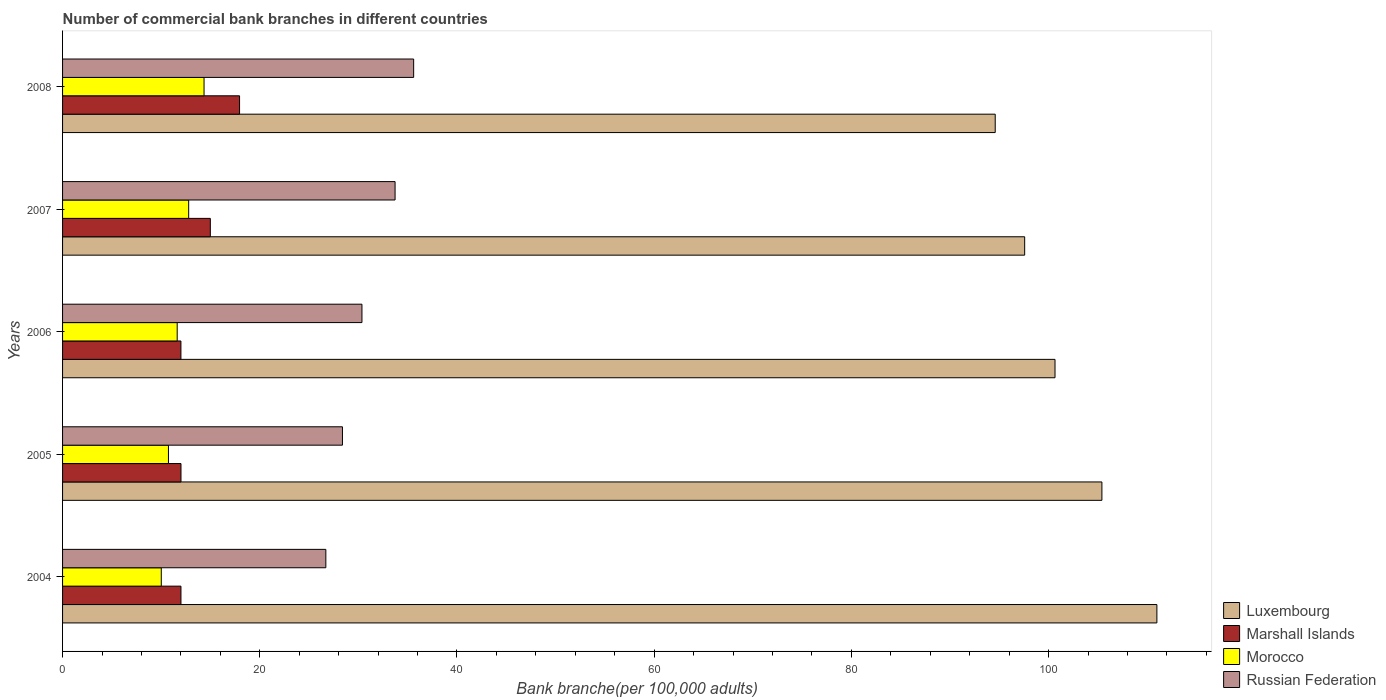How many different coloured bars are there?
Provide a short and direct response. 4. How many groups of bars are there?
Provide a succinct answer. 5. Are the number of bars per tick equal to the number of legend labels?
Provide a short and direct response. Yes. Are the number of bars on each tick of the Y-axis equal?
Your answer should be very brief. Yes. How many bars are there on the 3rd tick from the top?
Keep it short and to the point. 4. What is the label of the 5th group of bars from the top?
Your response must be concise. 2004. What is the number of commercial bank branches in Morocco in 2004?
Keep it short and to the point. 10.01. Across all years, what is the maximum number of commercial bank branches in Marshall Islands?
Your response must be concise. 17.95. Across all years, what is the minimum number of commercial bank branches in Russian Federation?
Offer a terse response. 26.7. In which year was the number of commercial bank branches in Marshall Islands maximum?
Provide a succinct answer. 2008. In which year was the number of commercial bank branches in Marshall Islands minimum?
Ensure brevity in your answer.  2006. What is the total number of commercial bank branches in Marshall Islands in the graph?
Offer a terse response. 68.95. What is the difference between the number of commercial bank branches in Russian Federation in 2004 and that in 2007?
Give a very brief answer. -7.02. What is the difference between the number of commercial bank branches in Luxembourg in 2004 and the number of commercial bank branches in Morocco in 2007?
Keep it short and to the point. 98.19. What is the average number of commercial bank branches in Morocco per year?
Provide a succinct answer. 11.9. In the year 2004, what is the difference between the number of commercial bank branches in Luxembourg and number of commercial bank branches in Russian Federation?
Your answer should be very brief. 84.28. In how many years, is the number of commercial bank branches in Morocco greater than 32 ?
Make the answer very short. 0. What is the ratio of the number of commercial bank branches in Luxembourg in 2005 to that in 2006?
Keep it short and to the point. 1.05. What is the difference between the highest and the second highest number of commercial bank branches in Luxembourg?
Provide a short and direct response. 5.58. What is the difference between the highest and the lowest number of commercial bank branches in Morocco?
Keep it short and to the point. 4.34. Is the sum of the number of commercial bank branches in Luxembourg in 2007 and 2008 greater than the maximum number of commercial bank branches in Russian Federation across all years?
Your answer should be very brief. Yes. Is it the case that in every year, the sum of the number of commercial bank branches in Marshall Islands and number of commercial bank branches in Luxembourg is greater than the sum of number of commercial bank branches in Morocco and number of commercial bank branches in Russian Federation?
Your answer should be very brief. Yes. What does the 1st bar from the top in 2007 represents?
Provide a short and direct response. Russian Federation. What does the 1st bar from the bottom in 2004 represents?
Provide a short and direct response. Luxembourg. Is it the case that in every year, the sum of the number of commercial bank branches in Marshall Islands and number of commercial bank branches in Morocco is greater than the number of commercial bank branches in Russian Federation?
Your answer should be compact. No. Does the graph contain any zero values?
Offer a terse response. No. How many legend labels are there?
Your answer should be very brief. 4. What is the title of the graph?
Offer a very short reply. Number of commercial bank branches in different countries. What is the label or title of the X-axis?
Keep it short and to the point. Bank branche(per 100,0 adults). What is the Bank branche(per 100,000 adults) in Luxembourg in 2004?
Ensure brevity in your answer.  110.98. What is the Bank branche(per 100,000 adults) in Marshall Islands in 2004?
Ensure brevity in your answer.  12.01. What is the Bank branche(per 100,000 adults) of Morocco in 2004?
Keep it short and to the point. 10.01. What is the Bank branche(per 100,000 adults) in Russian Federation in 2004?
Offer a terse response. 26.7. What is the Bank branche(per 100,000 adults) in Luxembourg in 2005?
Offer a terse response. 105.41. What is the Bank branche(per 100,000 adults) in Marshall Islands in 2005?
Give a very brief answer. 12.01. What is the Bank branche(per 100,000 adults) of Morocco in 2005?
Offer a very short reply. 10.74. What is the Bank branche(per 100,000 adults) of Russian Federation in 2005?
Your answer should be very brief. 28.38. What is the Bank branche(per 100,000 adults) in Luxembourg in 2006?
Provide a succinct answer. 100.65. What is the Bank branche(per 100,000 adults) in Marshall Islands in 2006?
Ensure brevity in your answer.  12. What is the Bank branche(per 100,000 adults) in Morocco in 2006?
Your answer should be very brief. 11.63. What is the Bank branche(per 100,000 adults) of Russian Federation in 2006?
Provide a short and direct response. 30.36. What is the Bank branche(per 100,000 adults) in Luxembourg in 2007?
Keep it short and to the point. 97.57. What is the Bank branche(per 100,000 adults) of Marshall Islands in 2007?
Provide a short and direct response. 14.99. What is the Bank branche(per 100,000 adults) in Morocco in 2007?
Keep it short and to the point. 12.79. What is the Bank branche(per 100,000 adults) of Russian Federation in 2007?
Offer a terse response. 33.72. What is the Bank branche(per 100,000 adults) in Luxembourg in 2008?
Provide a succinct answer. 94.59. What is the Bank branche(per 100,000 adults) in Marshall Islands in 2008?
Keep it short and to the point. 17.95. What is the Bank branche(per 100,000 adults) in Morocco in 2008?
Your answer should be very brief. 14.35. What is the Bank branche(per 100,000 adults) in Russian Federation in 2008?
Your response must be concise. 35.61. Across all years, what is the maximum Bank branche(per 100,000 adults) of Luxembourg?
Provide a short and direct response. 110.98. Across all years, what is the maximum Bank branche(per 100,000 adults) of Marshall Islands?
Provide a short and direct response. 17.95. Across all years, what is the maximum Bank branche(per 100,000 adults) of Morocco?
Make the answer very short. 14.35. Across all years, what is the maximum Bank branche(per 100,000 adults) of Russian Federation?
Keep it short and to the point. 35.61. Across all years, what is the minimum Bank branche(per 100,000 adults) in Luxembourg?
Give a very brief answer. 94.59. Across all years, what is the minimum Bank branche(per 100,000 adults) of Marshall Islands?
Ensure brevity in your answer.  12. Across all years, what is the minimum Bank branche(per 100,000 adults) in Morocco?
Provide a succinct answer. 10.01. Across all years, what is the minimum Bank branche(per 100,000 adults) of Russian Federation?
Provide a succinct answer. 26.7. What is the total Bank branche(per 100,000 adults) of Luxembourg in the graph?
Your response must be concise. 509.2. What is the total Bank branche(per 100,000 adults) in Marshall Islands in the graph?
Provide a succinct answer. 68.95. What is the total Bank branche(per 100,000 adults) in Morocco in the graph?
Offer a very short reply. 59.51. What is the total Bank branche(per 100,000 adults) of Russian Federation in the graph?
Offer a terse response. 154.78. What is the difference between the Bank branche(per 100,000 adults) of Luxembourg in 2004 and that in 2005?
Your answer should be very brief. 5.58. What is the difference between the Bank branche(per 100,000 adults) of Marshall Islands in 2004 and that in 2005?
Offer a terse response. -0. What is the difference between the Bank branche(per 100,000 adults) in Morocco in 2004 and that in 2005?
Provide a short and direct response. -0.73. What is the difference between the Bank branche(per 100,000 adults) in Russian Federation in 2004 and that in 2005?
Ensure brevity in your answer.  -1.68. What is the difference between the Bank branche(per 100,000 adults) of Luxembourg in 2004 and that in 2006?
Offer a very short reply. 10.33. What is the difference between the Bank branche(per 100,000 adults) of Marshall Islands in 2004 and that in 2006?
Your response must be concise. 0. What is the difference between the Bank branche(per 100,000 adults) of Morocco in 2004 and that in 2006?
Offer a terse response. -1.61. What is the difference between the Bank branche(per 100,000 adults) in Russian Federation in 2004 and that in 2006?
Provide a short and direct response. -3.66. What is the difference between the Bank branche(per 100,000 adults) of Luxembourg in 2004 and that in 2007?
Your answer should be very brief. 13.41. What is the difference between the Bank branche(per 100,000 adults) of Marshall Islands in 2004 and that in 2007?
Keep it short and to the point. -2.98. What is the difference between the Bank branche(per 100,000 adults) of Morocco in 2004 and that in 2007?
Provide a succinct answer. -2.78. What is the difference between the Bank branche(per 100,000 adults) in Russian Federation in 2004 and that in 2007?
Provide a succinct answer. -7.02. What is the difference between the Bank branche(per 100,000 adults) in Luxembourg in 2004 and that in 2008?
Offer a terse response. 16.4. What is the difference between the Bank branche(per 100,000 adults) of Marshall Islands in 2004 and that in 2008?
Your answer should be compact. -5.94. What is the difference between the Bank branche(per 100,000 adults) in Morocco in 2004 and that in 2008?
Make the answer very short. -4.34. What is the difference between the Bank branche(per 100,000 adults) of Russian Federation in 2004 and that in 2008?
Ensure brevity in your answer.  -8.91. What is the difference between the Bank branche(per 100,000 adults) of Luxembourg in 2005 and that in 2006?
Give a very brief answer. 4.76. What is the difference between the Bank branche(per 100,000 adults) in Marshall Islands in 2005 and that in 2006?
Your answer should be very brief. 0.01. What is the difference between the Bank branche(per 100,000 adults) of Morocco in 2005 and that in 2006?
Ensure brevity in your answer.  -0.89. What is the difference between the Bank branche(per 100,000 adults) in Russian Federation in 2005 and that in 2006?
Make the answer very short. -1.98. What is the difference between the Bank branche(per 100,000 adults) in Luxembourg in 2005 and that in 2007?
Keep it short and to the point. 7.83. What is the difference between the Bank branche(per 100,000 adults) of Marshall Islands in 2005 and that in 2007?
Make the answer very short. -2.98. What is the difference between the Bank branche(per 100,000 adults) in Morocco in 2005 and that in 2007?
Provide a short and direct response. -2.05. What is the difference between the Bank branche(per 100,000 adults) of Russian Federation in 2005 and that in 2007?
Your answer should be compact. -5.34. What is the difference between the Bank branche(per 100,000 adults) of Luxembourg in 2005 and that in 2008?
Offer a very short reply. 10.82. What is the difference between the Bank branche(per 100,000 adults) of Marshall Islands in 2005 and that in 2008?
Your answer should be very brief. -5.94. What is the difference between the Bank branche(per 100,000 adults) in Morocco in 2005 and that in 2008?
Your response must be concise. -3.61. What is the difference between the Bank branche(per 100,000 adults) of Russian Federation in 2005 and that in 2008?
Ensure brevity in your answer.  -7.22. What is the difference between the Bank branche(per 100,000 adults) of Luxembourg in 2006 and that in 2007?
Make the answer very short. 3.08. What is the difference between the Bank branche(per 100,000 adults) in Marshall Islands in 2006 and that in 2007?
Provide a succinct answer. -2.98. What is the difference between the Bank branche(per 100,000 adults) of Morocco in 2006 and that in 2007?
Ensure brevity in your answer.  -1.16. What is the difference between the Bank branche(per 100,000 adults) in Russian Federation in 2006 and that in 2007?
Your answer should be compact. -3.36. What is the difference between the Bank branche(per 100,000 adults) of Luxembourg in 2006 and that in 2008?
Offer a terse response. 6.06. What is the difference between the Bank branche(per 100,000 adults) of Marshall Islands in 2006 and that in 2008?
Offer a very short reply. -5.95. What is the difference between the Bank branche(per 100,000 adults) of Morocco in 2006 and that in 2008?
Provide a succinct answer. -2.72. What is the difference between the Bank branche(per 100,000 adults) of Russian Federation in 2006 and that in 2008?
Offer a terse response. -5.24. What is the difference between the Bank branche(per 100,000 adults) of Luxembourg in 2007 and that in 2008?
Offer a terse response. 2.99. What is the difference between the Bank branche(per 100,000 adults) in Marshall Islands in 2007 and that in 2008?
Your response must be concise. -2.96. What is the difference between the Bank branche(per 100,000 adults) in Morocco in 2007 and that in 2008?
Keep it short and to the point. -1.56. What is the difference between the Bank branche(per 100,000 adults) of Russian Federation in 2007 and that in 2008?
Your answer should be very brief. -1.89. What is the difference between the Bank branche(per 100,000 adults) in Luxembourg in 2004 and the Bank branche(per 100,000 adults) in Marshall Islands in 2005?
Keep it short and to the point. 98.97. What is the difference between the Bank branche(per 100,000 adults) in Luxembourg in 2004 and the Bank branche(per 100,000 adults) in Morocco in 2005?
Your response must be concise. 100.24. What is the difference between the Bank branche(per 100,000 adults) of Luxembourg in 2004 and the Bank branche(per 100,000 adults) of Russian Federation in 2005?
Your answer should be very brief. 82.6. What is the difference between the Bank branche(per 100,000 adults) of Marshall Islands in 2004 and the Bank branche(per 100,000 adults) of Morocco in 2005?
Provide a succinct answer. 1.27. What is the difference between the Bank branche(per 100,000 adults) in Marshall Islands in 2004 and the Bank branche(per 100,000 adults) in Russian Federation in 2005?
Your response must be concise. -16.38. What is the difference between the Bank branche(per 100,000 adults) in Morocco in 2004 and the Bank branche(per 100,000 adults) in Russian Federation in 2005?
Offer a terse response. -18.37. What is the difference between the Bank branche(per 100,000 adults) in Luxembourg in 2004 and the Bank branche(per 100,000 adults) in Marshall Islands in 2006?
Give a very brief answer. 98.98. What is the difference between the Bank branche(per 100,000 adults) in Luxembourg in 2004 and the Bank branche(per 100,000 adults) in Morocco in 2006?
Offer a terse response. 99.36. What is the difference between the Bank branche(per 100,000 adults) in Luxembourg in 2004 and the Bank branche(per 100,000 adults) in Russian Federation in 2006?
Keep it short and to the point. 80.62. What is the difference between the Bank branche(per 100,000 adults) of Marshall Islands in 2004 and the Bank branche(per 100,000 adults) of Morocco in 2006?
Your answer should be compact. 0.38. What is the difference between the Bank branche(per 100,000 adults) in Marshall Islands in 2004 and the Bank branche(per 100,000 adults) in Russian Federation in 2006?
Ensure brevity in your answer.  -18.36. What is the difference between the Bank branche(per 100,000 adults) of Morocco in 2004 and the Bank branche(per 100,000 adults) of Russian Federation in 2006?
Your answer should be very brief. -20.35. What is the difference between the Bank branche(per 100,000 adults) of Luxembourg in 2004 and the Bank branche(per 100,000 adults) of Marshall Islands in 2007?
Make the answer very short. 96. What is the difference between the Bank branche(per 100,000 adults) of Luxembourg in 2004 and the Bank branche(per 100,000 adults) of Morocco in 2007?
Your answer should be very brief. 98.19. What is the difference between the Bank branche(per 100,000 adults) in Luxembourg in 2004 and the Bank branche(per 100,000 adults) in Russian Federation in 2007?
Keep it short and to the point. 77.26. What is the difference between the Bank branche(per 100,000 adults) of Marshall Islands in 2004 and the Bank branche(per 100,000 adults) of Morocco in 2007?
Offer a terse response. -0.78. What is the difference between the Bank branche(per 100,000 adults) of Marshall Islands in 2004 and the Bank branche(per 100,000 adults) of Russian Federation in 2007?
Provide a short and direct response. -21.72. What is the difference between the Bank branche(per 100,000 adults) in Morocco in 2004 and the Bank branche(per 100,000 adults) in Russian Federation in 2007?
Give a very brief answer. -23.71. What is the difference between the Bank branche(per 100,000 adults) of Luxembourg in 2004 and the Bank branche(per 100,000 adults) of Marshall Islands in 2008?
Offer a very short reply. 93.03. What is the difference between the Bank branche(per 100,000 adults) in Luxembourg in 2004 and the Bank branche(per 100,000 adults) in Morocco in 2008?
Your response must be concise. 96.63. What is the difference between the Bank branche(per 100,000 adults) of Luxembourg in 2004 and the Bank branche(per 100,000 adults) of Russian Federation in 2008?
Give a very brief answer. 75.38. What is the difference between the Bank branche(per 100,000 adults) of Marshall Islands in 2004 and the Bank branche(per 100,000 adults) of Morocco in 2008?
Offer a terse response. -2.34. What is the difference between the Bank branche(per 100,000 adults) in Marshall Islands in 2004 and the Bank branche(per 100,000 adults) in Russian Federation in 2008?
Provide a short and direct response. -23.6. What is the difference between the Bank branche(per 100,000 adults) of Morocco in 2004 and the Bank branche(per 100,000 adults) of Russian Federation in 2008?
Ensure brevity in your answer.  -25.6. What is the difference between the Bank branche(per 100,000 adults) in Luxembourg in 2005 and the Bank branche(per 100,000 adults) in Marshall Islands in 2006?
Offer a very short reply. 93.4. What is the difference between the Bank branche(per 100,000 adults) of Luxembourg in 2005 and the Bank branche(per 100,000 adults) of Morocco in 2006?
Your answer should be very brief. 93.78. What is the difference between the Bank branche(per 100,000 adults) in Luxembourg in 2005 and the Bank branche(per 100,000 adults) in Russian Federation in 2006?
Offer a terse response. 75.04. What is the difference between the Bank branche(per 100,000 adults) of Marshall Islands in 2005 and the Bank branche(per 100,000 adults) of Morocco in 2006?
Your answer should be compact. 0.38. What is the difference between the Bank branche(per 100,000 adults) of Marshall Islands in 2005 and the Bank branche(per 100,000 adults) of Russian Federation in 2006?
Offer a terse response. -18.35. What is the difference between the Bank branche(per 100,000 adults) of Morocco in 2005 and the Bank branche(per 100,000 adults) of Russian Federation in 2006?
Your response must be concise. -19.62. What is the difference between the Bank branche(per 100,000 adults) of Luxembourg in 2005 and the Bank branche(per 100,000 adults) of Marshall Islands in 2007?
Offer a terse response. 90.42. What is the difference between the Bank branche(per 100,000 adults) in Luxembourg in 2005 and the Bank branche(per 100,000 adults) in Morocco in 2007?
Provide a short and direct response. 92.62. What is the difference between the Bank branche(per 100,000 adults) in Luxembourg in 2005 and the Bank branche(per 100,000 adults) in Russian Federation in 2007?
Offer a very short reply. 71.69. What is the difference between the Bank branche(per 100,000 adults) in Marshall Islands in 2005 and the Bank branche(per 100,000 adults) in Morocco in 2007?
Provide a short and direct response. -0.78. What is the difference between the Bank branche(per 100,000 adults) of Marshall Islands in 2005 and the Bank branche(per 100,000 adults) of Russian Federation in 2007?
Offer a very short reply. -21.71. What is the difference between the Bank branche(per 100,000 adults) of Morocco in 2005 and the Bank branche(per 100,000 adults) of Russian Federation in 2007?
Offer a very short reply. -22.98. What is the difference between the Bank branche(per 100,000 adults) in Luxembourg in 2005 and the Bank branche(per 100,000 adults) in Marshall Islands in 2008?
Provide a succinct answer. 87.46. What is the difference between the Bank branche(per 100,000 adults) in Luxembourg in 2005 and the Bank branche(per 100,000 adults) in Morocco in 2008?
Your answer should be compact. 91.06. What is the difference between the Bank branche(per 100,000 adults) of Luxembourg in 2005 and the Bank branche(per 100,000 adults) of Russian Federation in 2008?
Your response must be concise. 69.8. What is the difference between the Bank branche(per 100,000 adults) in Marshall Islands in 2005 and the Bank branche(per 100,000 adults) in Morocco in 2008?
Make the answer very short. -2.34. What is the difference between the Bank branche(per 100,000 adults) of Marshall Islands in 2005 and the Bank branche(per 100,000 adults) of Russian Federation in 2008?
Provide a succinct answer. -23.6. What is the difference between the Bank branche(per 100,000 adults) of Morocco in 2005 and the Bank branche(per 100,000 adults) of Russian Federation in 2008?
Your answer should be compact. -24.87. What is the difference between the Bank branche(per 100,000 adults) of Luxembourg in 2006 and the Bank branche(per 100,000 adults) of Marshall Islands in 2007?
Give a very brief answer. 85.67. What is the difference between the Bank branche(per 100,000 adults) in Luxembourg in 2006 and the Bank branche(per 100,000 adults) in Morocco in 2007?
Make the answer very short. 87.86. What is the difference between the Bank branche(per 100,000 adults) of Luxembourg in 2006 and the Bank branche(per 100,000 adults) of Russian Federation in 2007?
Your response must be concise. 66.93. What is the difference between the Bank branche(per 100,000 adults) of Marshall Islands in 2006 and the Bank branche(per 100,000 adults) of Morocco in 2007?
Provide a succinct answer. -0.79. What is the difference between the Bank branche(per 100,000 adults) in Marshall Islands in 2006 and the Bank branche(per 100,000 adults) in Russian Federation in 2007?
Ensure brevity in your answer.  -21.72. What is the difference between the Bank branche(per 100,000 adults) in Morocco in 2006 and the Bank branche(per 100,000 adults) in Russian Federation in 2007?
Offer a terse response. -22.1. What is the difference between the Bank branche(per 100,000 adults) of Luxembourg in 2006 and the Bank branche(per 100,000 adults) of Marshall Islands in 2008?
Offer a very short reply. 82.7. What is the difference between the Bank branche(per 100,000 adults) of Luxembourg in 2006 and the Bank branche(per 100,000 adults) of Morocco in 2008?
Provide a succinct answer. 86.3. What is the difference between the Bank branche(per 100,000 adults) of Luxembourg in 2006 and the Bank branche(per 100,000 adults) of Russian Federation in 2008?
Give a very brief answer. 65.04. What is the difference between the Bank branche(per 100,000 adults) of Marshall Islands in 2006 and the Bank branche(per 100,000 adults) of Morocco in 2008?
Keep it short and to the point. -2.35. What is the difference between the Bank branche(per 100,000 adults) of Marshall Islands in 2006 and the Bank branche(per 100,000 adults) of Russian Federation in 2008?
Your answer should be very brief. -23.6. What is the difference between the Bank branche(per 100,000 adults) of Morocco in 2006 and the Bank branche(per 100,000 adults) of Russian Federation in 2008?
Provide a short and direct response. -23.98. What is the difference between the Bank branche(per 100,000 adults) of Luxembourg in 2007 and the Bank branche(per 100,000 adults) of Marshall Islands in 2008?
Make the answer very short. 79.62. What is the difference between the Bank branche(per 100,000 adults) in Luxembourg in 2007 and the Bank branche(per 100,000 adults) in Morocco in 2008?
Your answer should be very brief. 83.22. What is the difference between the Bank branche(per 100,000 adults) in Luxembourg in 2007 and the Bank branche(per 100,000 adults) in Russian Federation in 2008?
Provide a short and direct response. 61.97. What is the difference between the Bank branche(per 100,000 adults) of Marshall Islands in 2007 and the Bank branche(per 100,000 adults) of Morocco in 2008?
Provide a short and direct response. 0.64. What is the difference between the Bank branche(per 100,000 adults) of Marshall Islands in 2007 and the Bank branche(per 100,000 adults) of Russian Federation in 2008?
Keep it short and to the point. -20.62. What is the difference between the Bank branche(per 100,000 adults) of Morocco in 2007 and the Bank branche(per 100,000 adults) of Russian Federation in 2008?
Your answer should be compact. -22.82. What is the average Bank branche(per 100,000 adults) in Luxembourg per year?
Your response must be concise. 101.84. What is the average Bank branche(per 100,000 adults) in Marshall Islands per year?
Your response must be concise. 13.79. What is the average Bank branche(per 100,000 adults) in Morocco per year?
Give a very brief answer. 11.9. What is the average Bank branche(per 100,000 adults) in Russian Federation per year?
Offer a terse response. 30.96. In the year 2004, what is the difference between the Bank branche(per 100,000 adults) of Luxembourg and Bank branche(per 100,000 adults) of Marshall Islands?
Make the answer very short. 98.98. In the year 2004, what is the difference between the Bank branche(per 100,000 adults) of Luxembourg and Bank branche(per 100,000 adults) of Morocco?
Make the answer very short. 100.97. In the year 2004, what is the difference between the Bank branche(per 100,000 adults) of Luxembourg and Bank branche(per 100,000 adults) of Russian Federation?
Offer a terse response. 84.28. In the year 2004, what is the difference between the Bank branche(per 100,000 adults) of Marshall Islands and Bank branche(per 100,000 adults) of Morocco?
Make the answer very short. 1.99. In the year 2004, what is the difference between the Bank branche(per 100,000 adults) in Marshall Islands and Bank branche(per 100,000 adults) in Russian Federation?
Your answer should be compact. -14.69. In the year 2004, what is the difference between the Bank branche(per 100,000 adults) of Morocco and Bank branche(per 100,000 adults) of Russian Federation?
Your answer should be very brief. -16.69. In the year 2005, what is the difference between the Bank branche(per 100,000 adults) of Luxembourg and Bank branche(per 100,000 adults) of Marshall Islands?
Make the answer very short. 93.4. In the year 2005, what is the difference between the Bank branche(per 100,000 adults) in Luxembourg and Bank branche(per 100,000 adults) in Morocco?
Make the answer very short. 94.67. In the year 2005, what is the difference between the Bank branche(per 100,000 adults) in Luxembourg and Bank branche(per 100,000 adults) in Russian Federation?
Provide a succinct answer. 77.02. In the year 2005, what is the difference between the Bank branche(per 100,000 adults) of Marshall Islands and Bank branche(per 100,000 adults) of Morocco?
Ensure brevity in your answer.  1.27. In the year 2005, what is the difference between the Bank branche(per 100,000 adults) of Marshall Islands and Bank branche(per 100,000 adults) of Russian Federation?
Ensure brevity in your answer.  -16.38. In the year 2005, what is the difference between the Bank branche(per 100,000 adults) in Morocco and Bank branche(per 100,000 adults) in Russian Federation?
Provide a succinct answer. -17.65. In the year 2006, what is the difference between the Bank branche(per 100,000 adults) of Luxembourg and Bank branche(per 100,000 adults) of Marshall Islands?
Your answer should be compact. 88.65. In the year 2006, what is the difference between the Bank branche(per 100,000 adults) of Luxembourg and Bank branche(per 100,000 adults) of Morocco?
Your answer should be compact. 89.03. In the year 2006, what is the difference between the Bank branche(per 100,000 adults) of Luxembourg and Bank branche(per 100,000 adults) of Russian Federation?
Your response must be concise. 70.29. In the year 2006, what is the difference between the Bank branche(per 100,000 adults) in Marshall Islands and Bank branche(per 100,000 adults) in Morocco?
Offer a terse response. 0.38. In the year 2006, what is the difference between the Bank branche(per 100,000 adults) of Marshall Islands and Bank branche(per 100,000 adults) of Russian Federation?
Provide a succinct answer. -18.36. In the year 2006, what is the difference between the Bank branche(per 100,000 adults) in Morocco and Bank branche(per 100,000 adults) in Russian Federation?
Your answer should be very brief. -18.74. In the year 2007, what is the difference between the Bank branche(per 100,000 adults) of Luxembourg and Bank branche(per 100,000 adults) of Marshall Islands?
Your answer should be compact. 82.59. In the year 2007, what is the difference between the Bank branche(per 100,000 adults) in Luxembourg and Bank branche(per 100,000 adults) in Morocco?
Give a very brief answer. 84.78. In the year 2007, what is the difference between the Bank branche(per 100,000 adults) of Luxembourg and Bank branche(per 100,000 adults) of Russian Federation?
Provide a succinct answer. 63.85. In the year 2007, what is the difference between the Bank branche(per 100,000 adults) in Marshall Islands and Bank branche(per 100,000 adults) in Morocco?
Offer a very short reply. 2.2. In the year 2007, what is the difference between the Bank branche(per 100,000 adults) of Marshall Islands and Bank branche(per 100,000 adults) of Russian Federation?
Your answer should be compact. -18.74. In the year 2007, what is the difference between the Bank branche(per 100,000 adults) of Morocco and Bank branche(per 100,000 adults) of Russian Federation?
Your answer should be compact. -20.93. In the year 2008, what is the difference between the Bank branche(per 100,000 adults) in Luxembourg and Bank branche(per 100,000 adults) in Marshall Islands?
Your answer should be compact. 76.64. In the year 2008, what is the difference between the Bank branche(per 100,000 adults) of Luxembourg and Bank branche(per 100,000 adults) of Morocco?
Your response must be concise. 80.24. In the year 2008, what is the difference between the Bank branche(per 100,000 adults) in Luxembourg and Bank branche(per 100,000 adults) in Russian Federation?
Your answer should be compact. 58.98. In the year 2008, what is the difference between the Bank branche(per 100,000 adults) of Marshall Islands and Bank branche(per 100,000 adults) of Morocco?
Provide a succinct answer. 3.6. In the year 2008, what is the difference between the Bank branche(per 100,000 adults) in Marshall Islands and Bank branche(per 100,000 adults) in Russian Federation?
Ensure brevity in your answer.  -17.66. In the year 2008, what is the difference between the Bank branche(per 100,000 adults) in Morocco and Bank branche(per 100,000 adults) in Russian Federation?
Keep it short and to the point. -21.26. What is the ratio of the Bank branche(per 100,000 adults) in Luxembourg in 2004 to that in 2005?
Keep it short and to the point. 1.05. What is the ratio of the Bank branche(per 100,000 adults) in Marshall Islands in 2004 to that in 2005?
Offer a terse response. 1. What is the ratio of the Bank branche(per 100,000 adults) in Morocco in 2004 to that in 2005?
Keep it short and to the point. 0.93. What is the ratio of the Bank branche(per 100,000 adults) of Russian Federation in 2004 to that in 2005?
Your response must be concise. 0.94. What is the ratio of the Bank branche(per 100,000 adults) of Luxembourg in 2004 to that in 2006?
Make the answer very short. 1.1. What is the ratio of the Bank branche(per 100,000 adults) in Morocco in 2004 to that in 2006?
Keep it short and to the point. 0.86. What is the ratio of the Bank branche(per 100,000 adults) of Russian Federation in 2004 to that in 2006?
Your answer should be very brief. 0.88. What is the ratio of the Bank branche(per 100,000 adults) in Luxembourg in 2004 to that in 2007?
Offer a very short reply. 1.14. What is the ratio of the Bank branche(per 100,000 adults) of Marshall Islands in 2004 to that in 2007?
Give a very brief answer. 0.8. What is the ratio of the Bank branche(per 100,000 adults) of Morocco in 2004 to that in 2007?
Offer a very short reply. 0.78. What is the ratio of the Bank branche(per 100,000 adults) of Russian Federation in 2004 to that in 2007?
Your answer should be very brief. 0.79. What is the ratio of the Bank branche(per 100,000 adults) of Luxembourg in 2004 to that in 2008?
Offer a terse response. 1.17. What is the ratio of the Bank branche(per 100,000 adults) of Marshall Islands in 2004 to that in 2008?
Make the answer very short. 0.67. What is the ratio of the Bank branche(per 100,000 adults) in Morocco in 2004 to that in 2008?
Offer a very short reply. 0.7. What is the ratio of the Bank branche(per 100,000 adults) of Russian Federation in 2004 to that in 2008?
Give a very brief answer. 0.75. What is the ratio of the Bank branche(per 100,000 adults) of Luxembourg in 2005 to that in 2006?
Offer a very short reply. 1.05. What is the ratio of the Bank branche(per 100,000 adults) of Marshall Islands in 2005 to that in 2006?
Make the answer very short. 1. What is the ratio of the Bank branche(per 100,000 adults) in Morocco in 2005 to that in 2006?
Give a very brief answer. 0.92. What is the ratio of the Bank branche(per 100,000 adults) in Russian Federation in 2005 to that in 2006?
Your answer should be very brief. 0.93. What is the ratio of the Bank branche(per 100,000 adults) of Luxembourg in 2005 to that in 2007?
Make the answer very short. 1.08. What is the ratio of the Bank branche(per 100,000 adults) in Marshall Islands in 2005 to that in 2007?
Provide a short and direct response. 0.8. What is the ratio of the Bank branche(per 100,000 adults) of Morocco in 2005 to that in 2007?
Give a very brief answer. 0.84. What is the ratio of the Bank branche(per 100,000 adults) of Russian Federation in 2005 to that in 2007?
Provide a succinct answer. 0.84. What is the ratio of the Bank branche(per 100,000 adults) in Luxembourg in 2005 to that in 2008?
Keep it short and to the point. 1.11. What is the ratio of the Bank branche(per 100,000 adults) of Marshall Islands in 2005 to that in 2008?
Make the answer very short. 0.67. What is the ratio of the Bank branche(per 100,000 adults) of Morocco in 2005 to that in 2008?
Offer a very short reply. 0.75. What is the ratio of the Bank branche(per 100,000 adults) of Russian Federation in 2005 to that in 2008?
Your answer should be compact. 0.8. What is the ratio of the Bank branche(per 100,000 adults) in Luxembourg in 2006 to that in 2007?
Give a very brief answer. 1.03. What is the ratio of the Bank branche(per 100,000 adults) in Marshall Islands in 2006 to that in 2007?
Keep it short and to the point. 0.8. What is the ratio of the Bank branche(per 100,000 adults) in Morocco in 2006 to that in 2007?
Provide a short and direct response. 0.91. What is the ratio of the Bank branche(per 100,000 adults) in Russian Federation in 2006 to that in 2007?
Give a very brief answer. 0.9. What is the ratio of the Bank branche(per 100,000 adults) in Luxembourg in 2006 to that in 2008?
Provide a succinct answer. 1.06. What is the ratio of the Bank branche(per 100,000 adults) of Marshall Islands in 2006 to that in 2008?
Keep it short and to the point. 0.67. What is the ratio of the Bank branche(per 100,000 adults) of Morocco in 2006 to that in 2008?
Offer a very short reply. 0.81. What is the ratio of the Bank branche(per 100,000 adults) of Russian Federation in 2006 to that in 2008?
Your response must be concise. 0.85. What is the ratio of the Bank branche(per 100,000 adults) of Luxembourg in 2007 to that in 2008?
Provide a short and direct response. 1.03. What is the ratio of the Bank branche(per 100,000 adults) of Marshall Islands in 2007 to that in 2008?
Keep it short and to the point. 0.83. What is the ratio of the Bank branche(per 100,000 adults) of Morocco in 2007 to that in 2008?
Your response must be concise. 0.89. What is the ratio of the Bank branche(per 100,000 adults) in Russian Federation in 2007 to that in 2008?
Your response must be concise. 0.95. What is the difference between the highest and the second highest Bank branche(per 100,000 adults) of Luxembourg?
Keep it short and to the point. 5.58. What is the difference between the highest and the second highest Bank branche(per 100,000 adults) of Marshall Islands?
Make the answer very short. 2.96. What is the difference between the highest and the second highest Bank branche(per 100,000 adults) in Morocco?
Provide a succinct answer. 1.56. What is the difference between the highest and the second highest Bank branche(per 100,000 adults) of Russian Federation?
Your answer should be very brief. 1.89. What is the difference between the highest and the lowest Bank branche(per 100,000 adults) in Luxembourg?
Your answer should be very brief. 16.4. What is the difference between the highest and the lowest Bank branche(per 100,000 adults) of Marshall Islands?
Your answer should be very brief. 5.95. What is the difference between the highest and the lowest Bank branche(per 100,000 adults) of Morocco?
Provide a succinct answer. 4.34. What is the difference between the highest and the lowest Bank branche(per 100,000 adults) in Russian Federation?
Give a very brief answer. 8.91. 